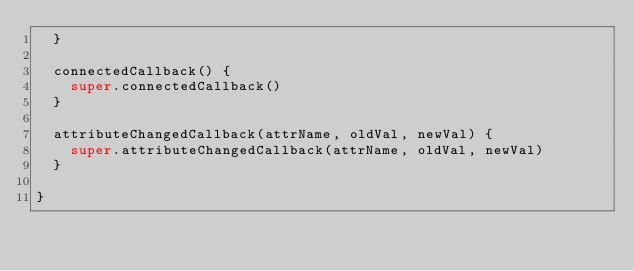Convert code to text. <code><loc_0><loc_0><loc_500><loc_500><_JavaScript_>  }

  connectedCallback() {
    super.connectedCallback()
  }

  attributeChangedCallback(attrName, oldVal, newVal) {
    super.attributeChangedCallback(attrName, oldVal, newVal)
  }

}
</code> 